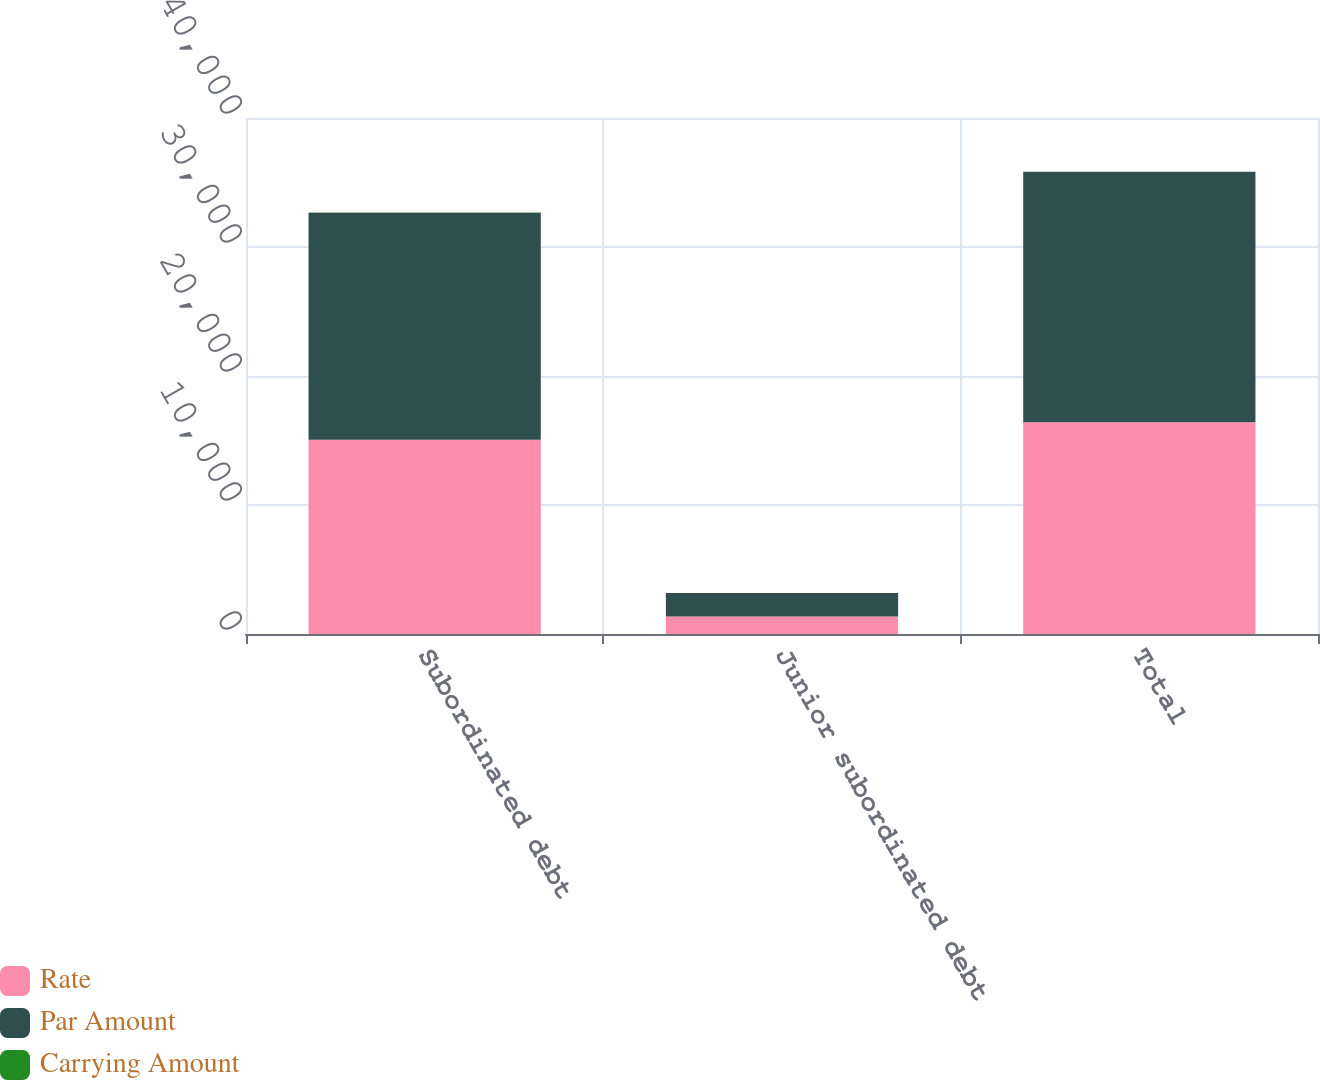Convert chart. <chart><loc_0><loc_0><loc_500><loc_500><stacked_bar_chart><ecel><fcel>Subordinated debt<fcel>Junior subordinated debt<fcel>Total<nl><fcel>Rate<fcel>15058<fcel>1360<fcel>16418<nl><fcel>Par Amount<fcel>17604<fcel>1809<fcel>19413<nl><fcel>Carrying Amount<fcel>4.29<fcel>5.7<fcel>4.41<nl></chart> 